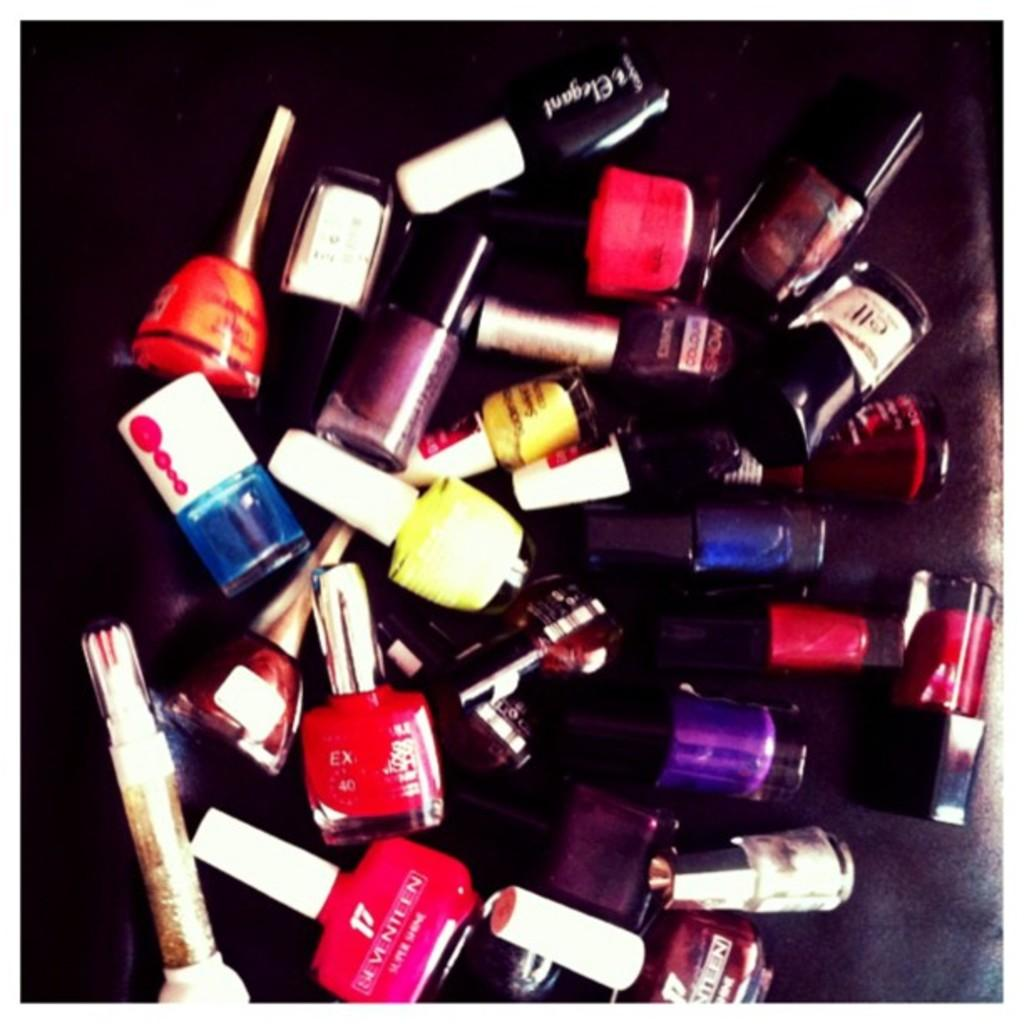What objects are in the image? There are nail-polish bottles in the image. Can you describe the nail-polish bottles? The nail-polish bottles have different colors. What is the color of the surface the bottles are on? The surface the bottles are on is black in color. What type of brick is being used to build the wall in the image? There is no wall or brick present in the image; it features nail-polish bottles on a black surface. How many sticks are visible in the image? There are no sticks present in the image. 